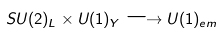Convert formula to latex. <formula><loc_0><loc_0><loc_500><loc_500>S U ( 2 ) _ { L } \times U ( 1 ) _ { Y } \longrightarrow U ( 1 ) _ { e m }</formula> 